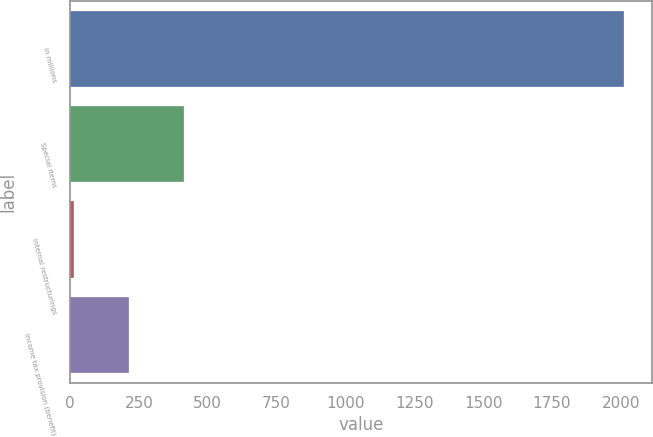<chart> <loc_0><loc_0><loc_500><loc_500><bar_chart><fcel>In millions<fcel>Special items<fcel>Internal restructurings<fcel>Income tax provision (benefit)<nl><fcel>2012<fcel>413.6<fcel>14<fcel>213.8<nl></chart> 